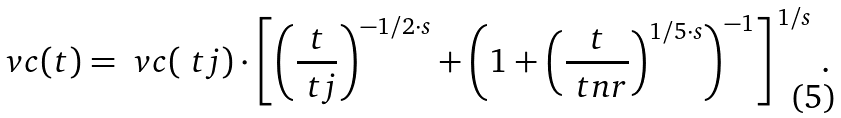<formula> <loc_0><loc_0><loc_500><loc_500>\ v c ( t ) = \ v c ( \ t j ) \cdot \left [ \left ( \frac { t } { \ t j } \right ) ^ { - 1 / 2 \cdot s } + \left ( 1 + \left ( \frac { t } { \ t n r } \right ) ^ { 1 / 5 \cdot s } \right ) ^ { - 1 } \right ] ^ { \, 1 / s } \, .</formula> 